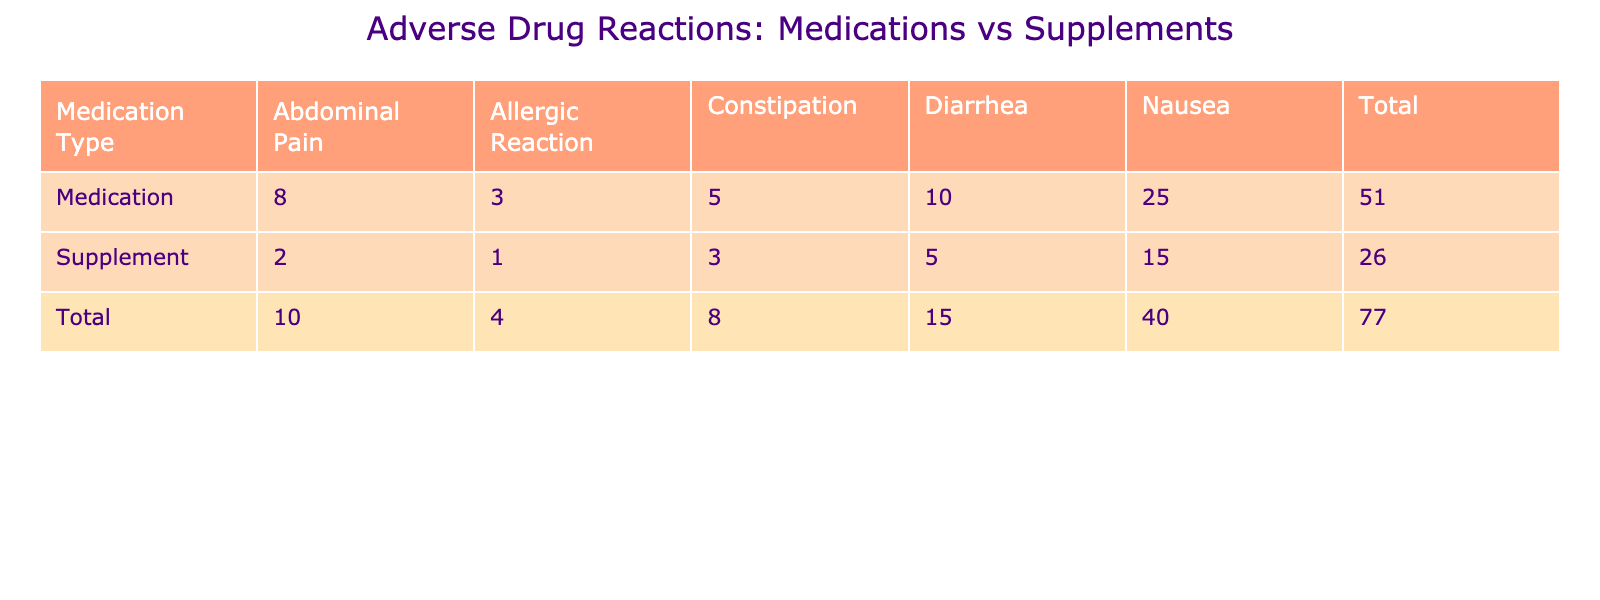What is the total number of adverse reactions reported for medications? To find the total number of adverse reactions for medications, I will sum the counts in the Medication row of the table. The counts for medications are 25 (Nausea) + 10 (Diarrhea) + 5 (Constipation) + 8 (Abdominal Pain) + 3 (Allergic Reaction) = 51.
Answer: 51 How many adverse reactions of ‘Diarrhea’ were reported for supplements? The table shows that there were 5 adverse reactions of Diarrhea reported for supplements directly in the Supplements row.
Answer: 5 Is there a higher total number of adverse reactions for medications compared to supplements? The total adverse reactions for medications is 51, while for supplements, the total is 26 (15 for Nausea + 5 for Diarrhea + 3 for Constipation + 2 for Abdominal Pain + 1 for Allergic Reaction). Since 51 > 26, it indicates that medications have a higher total.
Answer: Yes What is the difference in the number of allergic reactions reported between medications and supplements? From the table, medications reported 3 allergic reactions while supplements reported 1. The difference can be calculated as 3 (Medications) - 1 (Supplements) = 2.
Answer: 2 What percentage of adverse reactions from medications were due to Nausea? The total adverse reactions for medications is 51, and the count for Nausea is 25. The percentage is calculated as (25/51) * 100 ≈ 49.02%.
Answer: Approximately 49.02% Which adverse reaction had the highest count for medications, and what was that count? Looking at the Medication row, Nausea has the highest count of 25 compared to other reactions.
Answer: Nausea with a count of 25 What is the total number of adverse reactions reported across both medications and supplements? The total can be calculated by summing both totals: 51 (Medications) + 26 (Supplements) = 77.
Answer: 77 Among all adverse reactions, which had the lowest count and what was that count for each category? For medications, the lowest count is 3 (Allergic Reaction), and for supplements, the lowest is 1 (Allergic Reaction). This indicates that both categories had allergic reactions as the least reported adverse reaction.
Answer: 3 for medications and 1 for supplements What was the total number of adverse reactions attributed to gastrointestinal disturbances (Diarrhea, Constipation, and Abdominal Pain) for both medications and supplements? For medications, the total is 10 (Diarrhea) + 5 (Constipation) + 8 (Abdominal Pain) = 23. For supplements, the total is 5 (Diarrhea) + 3 (Constipation) + 2 (Abdominal Pain) = 10. Adding them together gives 23 + 10 = 33.
Answer: 33 